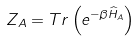<formula> <loc_0><loc_0><loc_500><loc_500>Z _ { A } = T r \left ( e ^ { - \beta \widehat { H } _ { A } } \right )</formula> 